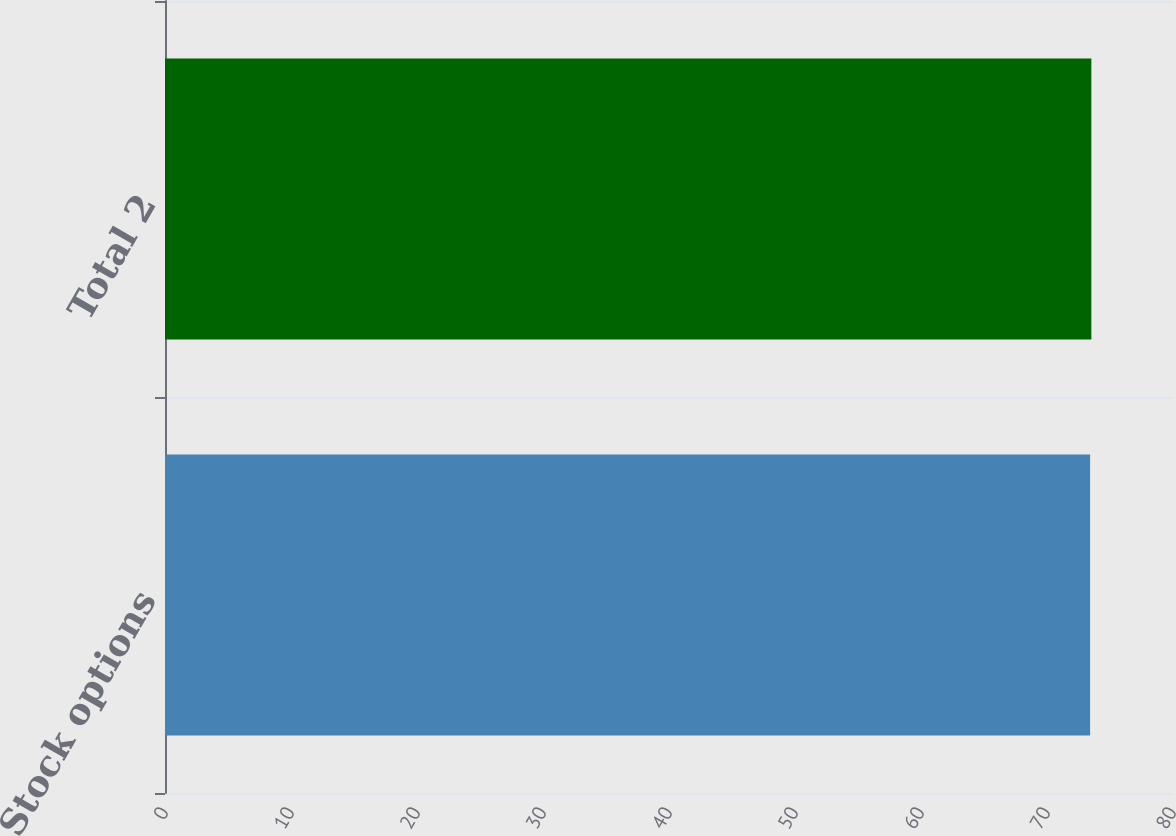Convert chart. <chart><loc_0><loc_0><loc_500><loc_500><bar_chart><fcel>Stock options<fcel>Total 2<nl><fcel>73.42<fcel>73.52<nl></chart> 